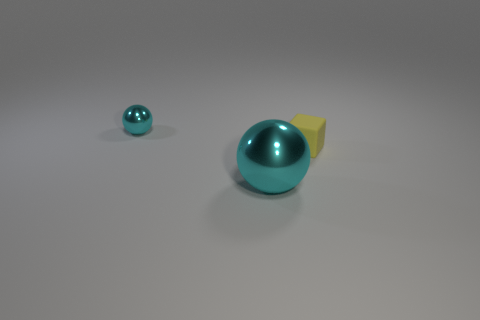Is there any other thing that is the same material as the small yellow block?
Your answer should be very brief. No. Are there more tiny cyan metallic things right of the small cyan metallic object than big blue matte objects?
Give a very brief answer. No. There is another thing that is made of the same material as the large cyan thing; what shape is it?
Ensure brevity in your answer.  Sphere. There is a sphere that is in front of the rubber object; is it the same size as the small yellow rubber thing?
Offer a terse response. No. There is a metal thing on the left side of the cyan object right of the small cyan metal object; what shape is it?
Your response must be concise. Sphere. There is a ball to the left of the cyan sphere that is in front of the yellow rubber thing; what is its size?
Your answer should be compact. Small. There is a shiny object in front of the small matte block; what color is it?
Make the answer very short. Cyan. There is a cyan object that is made of the same material as the big cyan ball; what is its size?
Your answer should be compact. Small. What number of small cyan shiny objects are the same shape as the big metallic thing?
Your response must be concise. 1. There is a ball that is the same size as the yellow rubber block; what is its material?
Make the answer very short. Metal. 